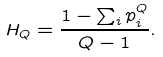Convert formula to latex. <formula><loc_0><loc_0><loc_500><loc_500>H _ { Q } = \frac { 1 - \sum _ { i } p _ { i } ^ { Q } } { Q - 1 } .</formula> 